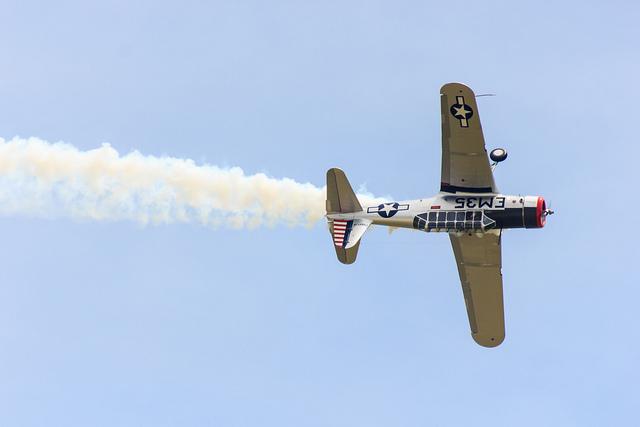What is coming out of the back of the airplane?
Short answer required. Smoke. Is the plane upside down?
Be succinct. Yes. What color is the bottom of the plane?
Be succinct. Blue. 